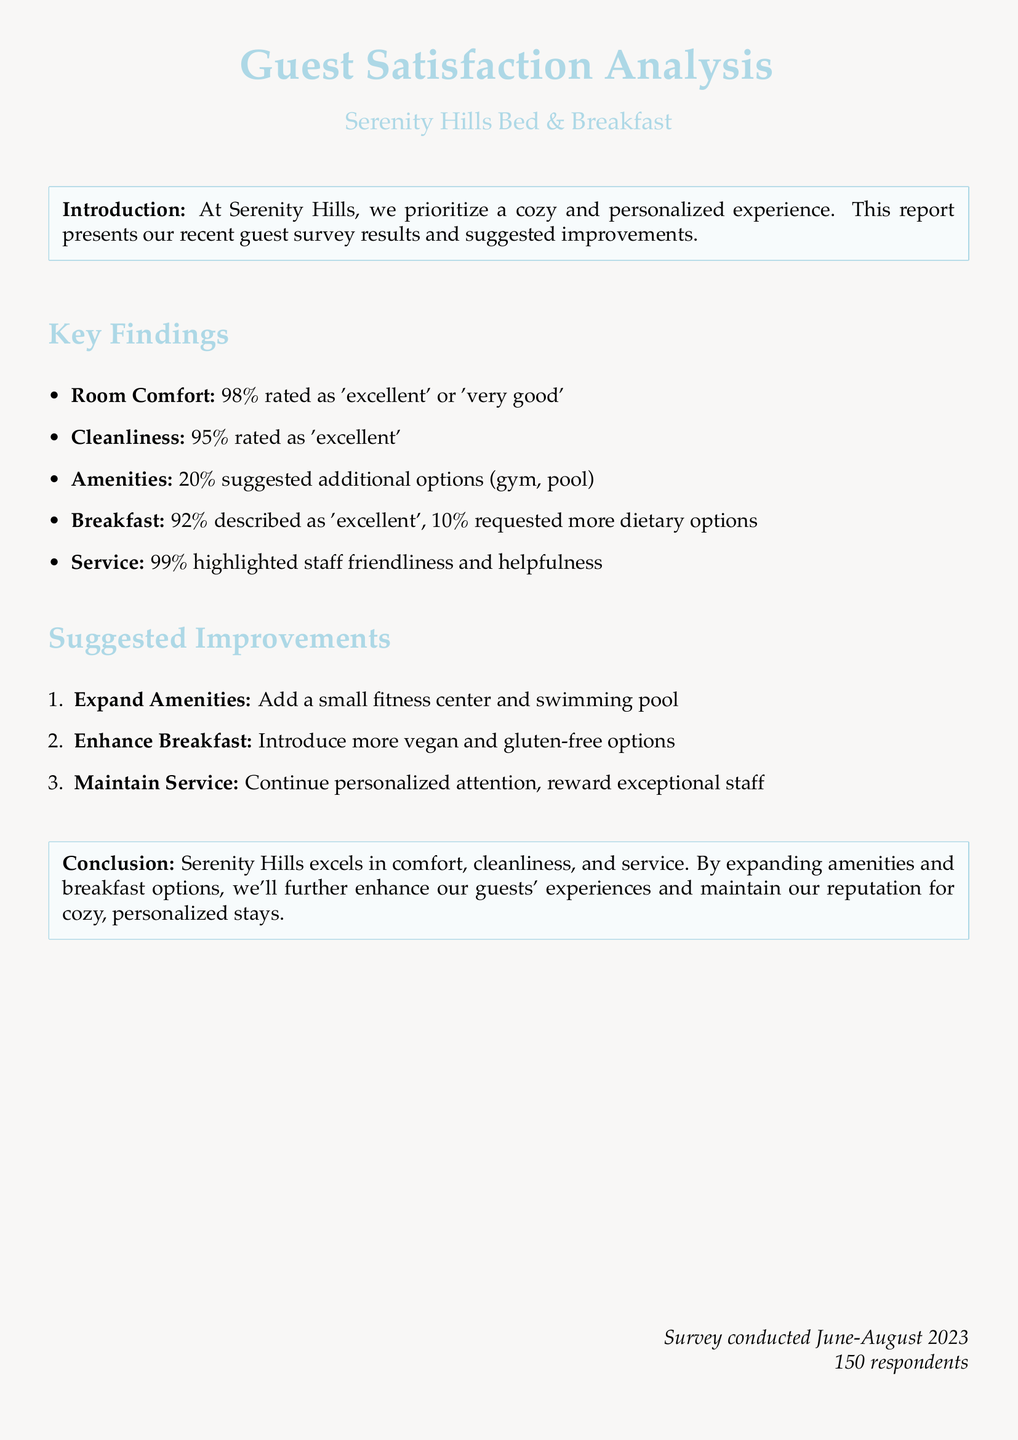What percentage of guests rated room comfort as 'excellent' or 'very good'? The document states that 98% of guests rated room comfort as 'excellent' or 'very good'.
Answer: 98% What is the cleanliness rating percentage of guests? The cleanliness rating shows that 95% of guests rated it as 'excellent'.
Answer: 95% How many respondents participated in the survey? The document mentions that there were 150 respondents in the survey.
Answer: 150 What percentage of guests suggested more dietary options for breakfast? According to the document, 10% of guests requested more dietary options for breakfast.
Answer: 10% What is the primary suggestion for expanding amenities? The document suggests adding a small fitness center and swimming pool to enhance amenities.
Answer: fitness center and swimming pool Which aspect of the service received the highest satisfaction rating? The document indicates that 99% highlighted staff friendliness and helpfulness, which is the highest rating.
Answer: 99% What dietary options are suggested to enhance breakfast? The document recommends introducing more vegan and gluten-free options for breakfast enhancements.
Answer: vegan and gluten-free options What is the overall conclusion about Serenity Hills? The document concludes that Serenity Hills excels in comfort, cleanliness, and service.
Answer: excels in comfort, cleanliness, and service 